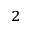<formula> <loc_0><loc_0><loc_500><loc_500>^ { 2 }</formula> 